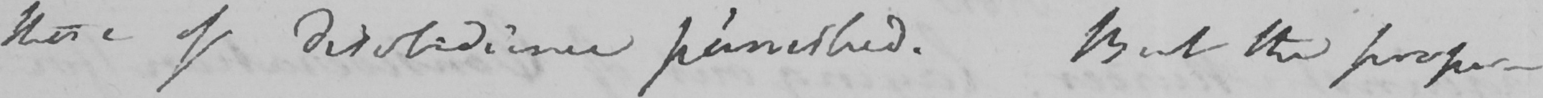What is written in this line of handwriting? those of disobedience punished . But the propor- 